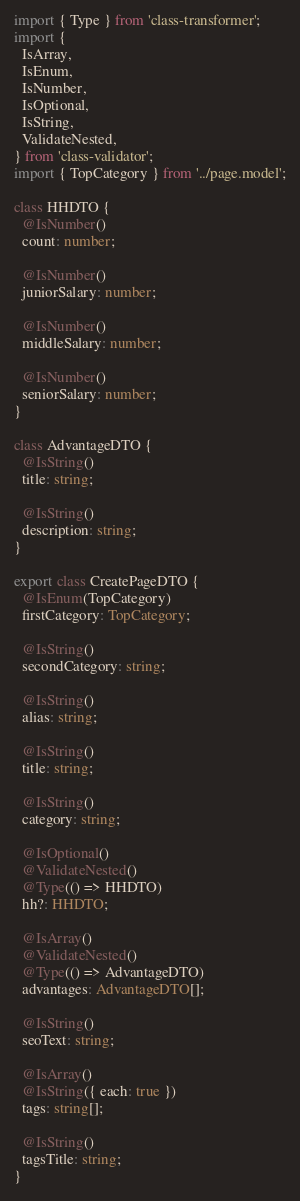<code> <loc_0><loc_0><loc_500><loc_500><_TypeScript_>import { Type } from 'class-transformer';
import {
  IsArray,
  IsEnum,
  IsNumber,
  IsOptional,
  IsString,
  ValidateNested,
} from 'class-validator';
import { TopCategory } from '../page.model';

class HHDTO {
  @IsNumber()
  count: number;

  @IsNumber()
  juniorSalary: number;

  @IsNumber()
  middleSalary: number;

  @IsNumber()
  seniorSalary: number;
}

class AdvantageDTO {
  @IsString()
  title: string;

  @IsString()
  description: string;
}

export class CreatePageDTO {
  @IsEnum(TopCategory)
  firstCategory: TopCategory;

  @IsString()
  secondCategory: string;

  @IsString()
  alias: string;

  @IsString()
  title: string;

  @IsString()
  category: string;

  @IsOptional()
  @ValidateNested()
  @Type(() => HHDTO)
  hh?: HHDTO;

  @IsArray()
  @ValidateNested()
  @Type(() => AdvantageDTO)
  advantages: AdvantageDTO[];

  @IsString()
  seoText: string;

  @IsArray()
  @IsString({ each: true })
  tags: string[];

  @IsString()
  tagsTitle: string;
}
</code> 